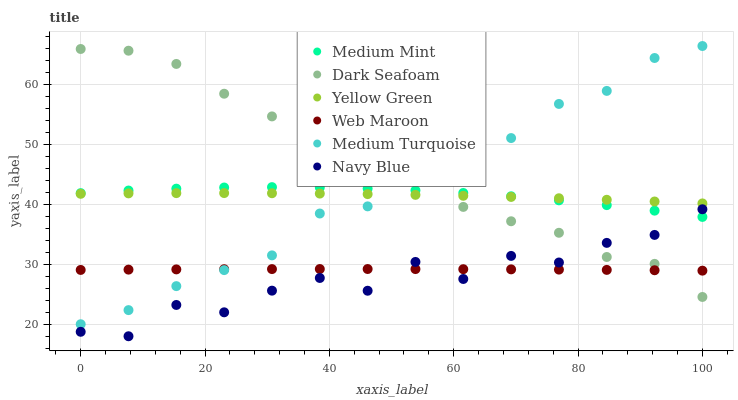Does Navy Blue have the minimum area under the curve?
Answer yes or no. Yes. Does Dark Seafoam have the maximum area under the curve?
Answer yes or no. Yes. Does Yellow Green have the minimum area under the curve?
Answer yes or no. No. Does Yellow Green have the maximum area under the curve?
Answer yes or no. No. Is Web Maroon the smoothest?
Answer yes or no. Yes. Is Navy Blue the roughest?
Answer yes or no. Yes. Is Yellow Green the smoothest?
Answer yes or no. No. Is Yellow Green the roughest?
Answer yes or no. No. Does Navy Blue have the lowest value?
Answer yes or no. Yes. Does Yellow Green have the lowest value?
Answer yes or no. No. Does Medium Turquoise have the highest value?
Answer yes or no. Yes. Does Yellow Green have the highest value?
Answer yes or no. No. Is Navy Blue less than Yellow Green?
Answer yes or no. Yes. Is Yellow Green greater than Navy Blue?
Answer yes or no. Yes. Does Medium Turquoise intersect Web Maroon?
Answer yes or no. Yes. Is Medium Turquoise less than Web Maroon?
Answer yes or no. No. Is Medium Turquoise greater than Web Maroon?
Answer yes or no. No. Does Navy Blue intersect Yellow Green?
Answer yes or no. No. 